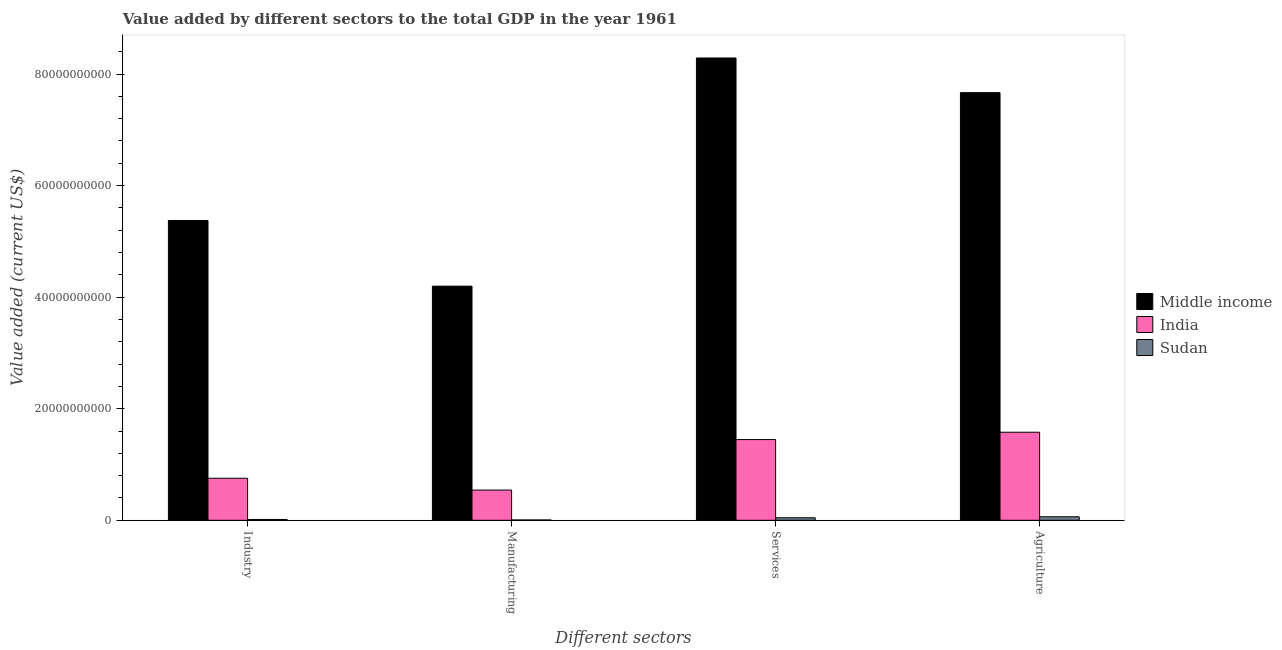How many different coloured bars are there?
Provide a succinct answer. 3. How many groups of bars are there?
Provide a short and direct response. 4. Are the number of bars on each tick of the X-axis equal?
Your answer should be very brief. Yes. What is the label of the 2nd group of bars from the left?
Provide a short and direct response. Manufacturing. What is the value added by agricultural sector in Sudan?
Your answer should be compact. 6.30e+08. Across all countries, what is the maximum value added by agricultural sector?
Keep it short and to the point. 7.67e+1. Across all countries, what is the minimum value added by industrial sector?
Your answer should be compact. 1.44e+08. In which country was the value added by industrial sector maximum?
Make the answer very short. Middle income. In which country was the value added by industrial sector minimum?
Provide a succinct answer. Sudan. What is the total value added by agricultural sector in the graph?
Make the answer very short. 9.31e+1. What is the difference between the value added by manufacturing sector in Sudan and that in Middle income?
Keep it short and to the point. -4.19e+1. What is the difference between the value added by agricultural sector in Middle income and the value added by industrial sector in Sudan?
Make the answer very short. 7.65e+1. What is the average value added by agricultural sector per country?
Give a very brief answer. 3.10e+1. What is the difference between the value added by industrial sector and value added by services sector in India?
Ensure brevity in your answer.  -6.94e+09. What is the ratio of the value added by agricultural sector in Sudan to that in India?
Your answer should be very brief. 0.04. Is the difference between the value added by services sector in Middle income and India greater than the difference between the value added by manufacturing sector in Middle income and India?
Offer a very short reply. Yes. What is the difference between the highest and the second highest value added by agricultural sector?
Your answer should be compact. 6.09e+1. What is the difference between the highest and the lowest value added by manufacturing sector?
Your answer should be compact. 4.19e+1. Is it the case that in every country, the sum of the value added by industrial sector and value added by manufacturing sector is greater than the sum of value added by agricultural sector and value added by services sector?
Offer a terse response. No. What does the 1st bar from the left in Manufacturing represents?
Offer a terse response. Middle income. What does the 1st bar from the right in Agriculture represents?
Offer a very short reply. Sudan. Is it the case that in every country, the sum of the value added by industrial sector and value added by manufacturing sector is greater than the value added by services sector?
Your response must be concise. No. How many bars are there?
Your answer should be compact. 12. Are the values on the major ticks of Y-axis written in scientific E-notation?
Offer a terse response. No. What is the title of the graph?
Your answer should be compact. Value added by different sectors to the total GDP in the year 1961. Does "Nepal" appear as one of the legend labels in the graph?
Your response must be concise. No. What is the label or title of the X-axis?
Provide a short and direct response. Different sectors. What is the label or title of the Y-axis?
Ensure brevity in your answer.  Value added (current US$). What is the Value added (current US$) of Middle income in Industry?
Make the answer very short. 5.37e+1. What is the Value added (current US$) of India in Industry?
Offer a terse response. 7.53e+09. What is the Value added (current US$) of Sudan in Industry?
Provide a succinct answer. 1.44e+08. What is the Value added (current US$) of Middle income in Manufacturing?
Make the answer very short. 4.20e+1. What is the Value added (current US$) of India in Manufacturing?
Your answer should be very brief. 5.41e+09. What is the Value added (current US$) of Sudan in Manufacturing?
Offer a very short reply. 5.40e+07. What is the Value added (current US$) of Middle income in Services?
Your answer should be very brief. 8.29e+1. What is the Value added (current US$) of India in Services?
Provide a succinct answer. 1.45e+1. What is the Value added (current US$) of Sudan in Services?
Your answer should be compact. 4.49e+08. What is the Value added (current US$) of Middle income in Agriculture?
Keep it short and to the point. 7.67e+1. What is the Value added (current US$) in India in Agriculture?
Provide a succinct answer. 1.58e+1. What is the Value added (current US$) in Sudan in Agriculture?
Your response must be concise. 6.30e+08. Across all Different sectors, what is the maximum Value added (current US$) of Middle income?
Make the answer very short. 8.29e+1. Across all Different sectors, what is the maximum Value added (current US$) in India?
Make the answer very short. 1.58e+1. Across all Different sectors, what is the maximum Value added (current US$) in Sudan?
Make the answer very short. 6.30e+08. Across all Different sectors, what is the minimum Value added (current US$) in Middle income?
Make the answer very short. 4.20e+1. Across all Different sectors, what is the minimum Value added (current US$) in India?
Your answer should be compact. 5.41e+09. Across all Different sectors, what is the minimum Value added (current US$) in Sudan?
Offer a very short reply. 5.40e+07. What is the total Value added (current US$) of Middle income in the graph?
Ensure brevity in your answer.  2.55e+11. What is the total Value added (current US$) of India in the graph?
Your response must be concise. 4.32e+1. What is the total Value added (current US$) of Sudan in the graph?
Your answer should be compact. 1.28e+09. What is the difference between the Value added (current US$) of Middle income in Industry and that in Manufacturing?
Provide a succinct answer. 1.18e+1. What is the difference between the Value added (current US$) of India in Industry and that in Manufacturing?
Offer a very short reply. 2.12e+09. What is the difference between the Value added (current US$) in Sudan in Industry and that in Manufacturing?
Provide a short and direct response. 9.05e+07. What is the difference between the Value added (current US$) in Middle income in Industry and that in Services?
Offer a terse response. -2.91e+1. What is the difference between the Value added (current US$) in India in Industry and that in Services?
Ensure brevity in your answer.  -6.94e+09. What is the difference between the Value added (current US$) in Sudan in Industry and that in Services?
Provide a succinct answer. -3.04e+08. What is the difference between the Value added (current US$) of Middle income in Industry and that in Agriculture?
Give a very brief answer. -2.29e+1. What is the difference between the Value added (current US$) in India in Industry and that in Agriculture?
Your answer should be compact. -8.25e+09. What is the difference between the Value added (current US$) in Sudan in Industry and that in Agriculture?
Ensure brevity in your answer.  -4.85e+08. What is the difference between the Value added (current US$) in Middle income in Manufacturing and that in Services?
Keep it short and to the point. -4.09e+1. What is the difference between the Value added (current US$) of India in Manufacturing and that in Services?
Provide a succinct answer. -9.05e+09. What is the difference between the Value added (current US$) in Sudan in Manufacturing and that in Services?
Your answer should be compact. -3.95e+08. What is the difference between the Value added (current US$) in Middle income in Manufacturing and that in Agriculture?
Make the answer very short. -3.47e+1. What is the difference between the Value added (current US$) in India in Manufacturing and that in Agriculture?
Give a very brief answer. -1.04e+1. What is the difference between the Value added (current US$) of Sudan in Manufacturing and that in Agriculture?
Your answer should be very brief. -5.76e+08. What is the difference between the Value added (current US$) of Middle income in Services and that in Agriculture?
Make the answer very short. 6.21e+09. What is the difference between the Value added (current US$) in India in Services and that in Agriculture?
Ensure brevity in your answer.  -1.32e+09. What is the difference between the Value added (current US$) of Sudan in Services and that in Agriculture?
Your response must be concise. -1.81e+08. What is the difference between the Value added (current US$) in Middle income in Industry and the Value added (current US$) in India in Manufacturing?
Your answer should be very brief. 4.83e+1. What is the difference between the Value added (current US$) in Middle income in Industry and the Value added (current US$) in Sudan in Manufacturing?
Provide a short and direct response. 5.37e+1. What is the difference between the Value added (current US$) in India in Industry and the Value added (current US$) in Sudan in Manufacturing?
Your answer should be compact. 7.48e+09. What is the difference between the Value added (current US$) in Middle income in Industry and the Value added (current US$) in India in Services?
Your answer should be very brief. 3.93e+1. What is the difference between the Value added (current US$) of Middle income in Industry and the Value added (current US$) of Sudan in Services?
Make the answer very short. 5.33e+1. What is the difference between the Value added (current US$) in India in Industry and the Value added (current US$) in Sudan in Services?
Provide a succinct answer. 7.08e+09. What is the difference between the Value added (current US$) in Middle income in Industry and the Value added (current US$) in India in Agriculture?
Offer a terse response. 3.80e+1. What is the difference between the Value added (current US$) in Middle income in Industry and the Value added (current US$) in Sudan in Agriculture?
Offer a very short reply. 5.31e+1. What is the difference between the Value added (current US$) of India in Industry and the Value added (current US$) of Sudan in Agriculture?
Your response must be concise. 6.90e+09. What is the difference between the Value added (current US$) in Middle income in Manufacturing and the Value added (current US$) in India in Services?
Your response must be concise. 2.75e+1. What is the difference between the Value added (current US$) in Middle income in Manufacturing and the Value added (current US$) in Sudan in Services?
Offer a very short reply. 4.15e+1. What is the difference between the Value added (current US$) in India in Manufacturing and the Value added (current US$) in Sudan in Services?
Your response must be concise. 4.96e+09. What is the difference between the Value added (current US$) in Middle income in Manufacturing and the Value added (current US$) in India in Agriculture?
Ensure brevity in your answer.  2.62e+1. What is the difference between the Value added (current US$) of Middle income in Manufacturing and the Value added (current US$) of Sudan in Agriculture?
Ensure brevity in your answer.  4.13e+1. What is the difference between the Value added (current US$) in India in Manufacturing and the Value added (current US$) in Sudan in Agriculture?
Your response must be concise. 4.78e+09. What is the difference between the Value added (current US$) in Middle income in Services and the Value added (current US$) in India in Agriculture?
Provide a succinct answer. 6.71e+1. What is the difference between the Value added (current US$) in Middle income in Services and the Value added (current US$) in Sudan in Agriculture?
Give a very brief answer. 8.22e+1. What is the difference between the Value added (current US$) in India in Services and the Value added (current US$) in Sudan in Agriculture?
Offer a terse response. 1.38e+1. What is the average Value added (current US$) in Middle income per Different sectors?
Keep it short and to the point. 6.38e+1. What is the average Value added (current US$) of India per Different sectors?
Make the answer very short. 1.08e+1. What is the average Value added (current US$) in Sudan per Different sectors?
Provide a succinct answer. 3.19e+08. What is the difference between the Value added (current US$) in Middle income and Value added (current US$) in India in Industry?
Ensure brevity in your answer.  4.62e+1. What is the difference between the Value added (current US$) in Middle income and Value added (current US$) in Sudan in Industry?
Your response must be concise. 5.36e+1. What is the difference between the Value added (current US$) in India and Value added (current US$) in Sudan in Industry?
Provide a short and direct response. 7.39e+09. What is the difference between the Value added (current US$) in Middle income and Value added (current US$) in India in Manufacturing?
Your response must be concise. 3.66e+1. What is the difference between the Value added (current US$) of Middle income and Value added (current US$) of Sudan in Manufacturing?
Offer a terse response. 4.19e+1. What is the difference between the Value added (current US$) in India and Value added (current US$) in Sudan in Manufacturing?
Offer a terse response. 5.36e+09. What is the difference between the Value added (current US$) of Middle income and Value added (current US$) of India in Services?
Your answer should be very brief. 6.84e+1. What is the difference between the Value added (current US$) in Middle income and Value added (current US$) in Sudan in Services?
Your answer should be very brief. 8.24e+1. What is the difference between the Value added (current US$) in India and Value added (current US$) in Sudan in Services?
Keep it short and to the point. 1.40e+1. What is the difference between the Value added (current US$) of Middle income and Value added (current US$) of India in Agriculture?
Ensure brevity in your answer.  6.09e+1. What is the difference between the Value added (current US$) of Middle income and Value added (current US$) of Sudan in Agriculture?
Provide a short and direct response. 7.60e+1. What is the difference between the Value added (current US$) of India and Value added (current US$) of Sudan in Agriculture?
Provide a succinct answer. 1.52e+1. What is the ratio of the Value added (current US$) in Middle income in Industry to that in Manufacturing?
Provide a succinct answer. 1.28. What is the ratio of the Value added (current US$) in India in Industry to that in Manufacturing?
Offer a terse response. 1.39. What is the ratio of the Value added (current US$) of Sudan in Industry to that in Manufacturing?
Your answer should be very brief. 2.68. What is the ratio of the Value added (current US$) of Middle income in Industry to that in Services?
Provide a succinct answer. 0.65. What is the ratio of the Value added (current US$) of India in Industry to that in Services?
Your response must be concise. 0.52. What is the ratio of the Value added (current US$) in Sudan in Industry to that in Services?
Provide a succinct answer. 0.32. What is the ratio of the Value added (current US$) in Middle income in Industry to that in Agriculture?
Keep it short and to the point. 0.7. What is the ratio of the Value added (current US$) in India in Industry to that in Agriculture?
Make the answer very short. 0.48. What is the ratio of the Value added (current US$) in Sudan in Industry to that in Agriculture?
Your response must be concise. 0.23. What is the ratio of the Value added (current US$) in Middle income in Manufacturing to that in Services?
Your answer should be compact. 0.51. What is the ratio of the Value added (current US$) of India in Manufacturing to that in Services?
Give a very brief answer. 0.37. What is the ratio of the Value added (current US$) in Sudan in Manufacturing to that in Services?
Make the answer very short. 0.12. What is the ratio of the Value added (current US$) in Middle income in Manufacturing to that in Agriculture?
Your answer should be very brief. 0.55. What is the ratio of the Value added (current US$) of India in Manufacturing to that in Agriculture?
Provide a short and direct response. 0.34. What is the ratio of the Value added (current US$) of Sudan in Manufacturing to that in Agriculture?
Keep it short and to the point. 0.09. What is the ratio of the Value added (current US$) in Middle income in Services to that in Agriculture?
Offer a very short reply. 1.08. What is the ratio of the Value added (current US$) in Sudan in Services to that in Agriculture?
Ensure brevity in your answer.  0.71. What is the difference between the highest and the second highest Value added (current US$) of Middle income?
Ensure brevity in your answer.  6.21e+09. What is the difference between the highest and the second highest Value added (current US$) in India?
Your answer should be compact. 1.32e+09. What is the difference between the highest and the second highest Value added (current US$) of Sudan?
Provide a succinct answer. 1.81e+08. What is the difference between the highest and the lowest Value added (current US$) in Middle income?
Offer a very short reply. 4.09e+1. What is the difference between the highest and the lowest Value added (current US$) in India?
Your answer should be compact. 1.04e+1. What is the difference between the highest and the lowest Value added (current US$) of Sudan?
Give a very brief answer. 5.76e+08. 